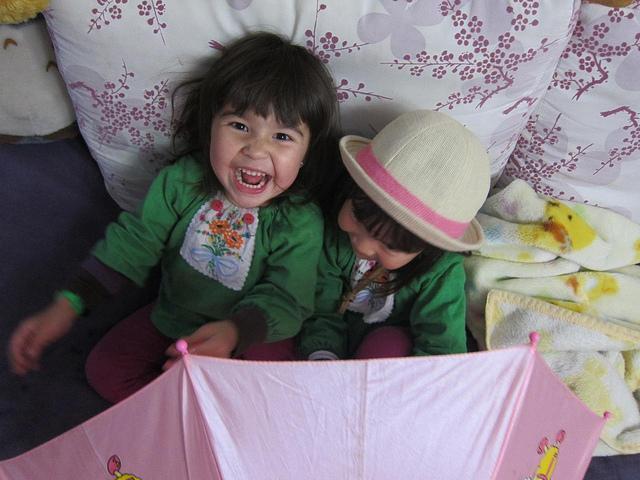What does it look like these girls are?
From the following set of four choices, select the accurate answer to respond to the question.
Options: Different genders, different parents, twins, different races. Twins. 